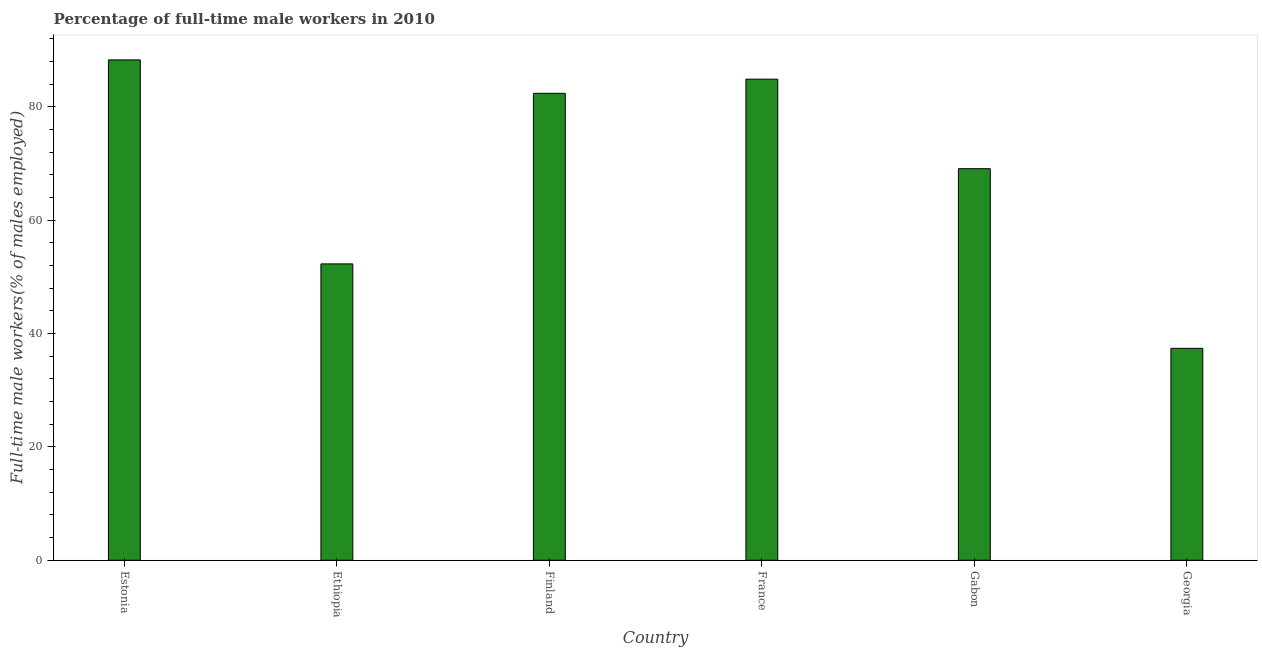What is the title of the graph?
Provide a succinct answer. Percentage of full-time male workers in 2010. What is the label or title of the X-axis?
Your response must be concise. Country. What is the label or title of the Y-axis?
Provide a short and direct response. Full-time male workers(% of males employed). What is the percentage of full-time male workers in Finland?
Your response must be concise. 82.4. Across all countries, what is the maximum percentage of full-time male workers?
Your answer should be very brief. 88.3. Across all countries, what is the minimum percentage of full-time male workers?
Your answer should be compact. 37.4. In which country was the percentage of full-time male workers maximum?
Provide a short and direct response. Estonia. In which country was the percentage of full-time male workers minimum?
Keep it short and to the point. Georgia. What is the sum of the percentage of full-time male workers?
Provide a succinct answer. 414.4. What is the average percentage of full-time male workers per country?
Make the answer very short. 69.07. What is the median percentage of full-time male workers?
Give a very brief answer. 75.75. In how many countries, is the percentage of full-time male workers greater than 72 %?
Make the answer very short. 3. What is the ratio of the percentage of full-time male workers in Ethiopia to that in Gabon?
Your response must be concise. 0.76. Is the sum of the percentage of full-time male workers in Ethiopia and France greater than the maximum percentage of full-time male workers across all countries?
Ensure brevity in your answer.  Yes. What is the difference between the highest and the lowest percentage of full-time male workers?
Offer a terse response. 50.9. In how many countries, is the percentage of full-time male workers greater than the average percentage of full-time male workers taken over all countries?
Ensure brevity in your answer.  4. How many bars are there?
Your answer should be compact. 6. Are all the bars in the graph horizontal?
Your answer should be very brief. No. How many countries are there in the graph?
Provide a short and direct response. 6. What is the Full-time male workers(% of males employed) in Estonia?
Make the answer very short. 88.3. What is the Full-time male workers(% of males employed) of Ethiopia?
Your response must be concise. 52.3. What is the Full-time male workers(% of males employed) of Finland?
Give a very brief answer. 82.4. What is the Full-time male workers(% of males employed) of France?
Offer a terse response. 84.9. What is the Full-time male workers(% of males employed) of Gabon?
Keep it short and to the point. 69.1. What is the Full-time male workers(% of males employed) of Georgia?
Your response must be concise. 37.4. What is the difference between the Full-time male workers(% of males employed) in Estonia and Gabon?
Provide a succinct answer. 19.2. What is the difference between the Full-time male workers(% of males employed) in Estonia and Georgia?
Make the answer very short. 50.9. What is the difference between the Full-time male workers(% of males employed) in Ethiopia and Finland?
Offer a very short reply. -30.1. What is the difference between the Full-time male workers(% of males employed) in Ethiopia and France?
Offer a terse response. -32.6. What is the difference between the Full-time male workers(% of males employed) in Ethiopia and Gabon?
Your response must be concise. -16.8. What is the difference between the Full-time male workers(% of males employed) in Finland and France?
Your response must be concise. -2.5. What is the difference between the Full-time male workers(% of males employed) in Finland and Georgia?
Provide a short and direct response. 45. What is the difference between the Full-time male workers(% of males employed) in France and Gabon?
Provide a succinct answer. 15.8. What is the difference between the Full-time male workers(% of males employed) in France and Georgia?
Provide a succinct answer. 47.5. What is the difference between the Full-time male workers(% of males employed) in Gabon and Georgia?
Your response must be concise. 31.7. What is the ratio of the Full-time male workers(% of males employed) in Estonia to that in Ethiopia?
Ensure brevity in your answer.  1.69. What is the ratio of the Full-time male workers(% of males employed) in Estonia to that in Finland?
Keep it short and to the point. 1.07. What is the ratio of the Full-time male workers(% of males employed) in Estonia to that in Gabon?
Your answer should be very brief. 1.28. What is the ratio of the Full-time male workers(% of males employed) in Estonia to that in Georgia?
Offer a terse response. 2.36. What is the ratio of the Full-time male workers(% of males employed) in Ethiopia to that in Finland?
Offer a very short reply. 0.64. What is the ratio of the Full-time male workers(% of males employed) in Ethiopia to that in France?
Provide a short and direct response. 0.62. What is the ratio of the Full-time male workers(% of males employed) in Ethiopia to that in Gabon?
Make the answer very short. 0.76. What is the ratio of the Full-time male workers(% of males employed) in Ethiopia to that in Georgia?
Make the answer very short. 1.4. What is the ratio of the Full-time male workers(% of males employed) in Finland to that in France?
Keep it short and to the point. 0.97. What is the ratio of the Full-time male workers(% of males employed) in Finland to that in Gabon?
Your answer should be compact. 1.19. What is the ratio of the Full-time male workers(% of males employed) in Finland to that in Georgia?
Keep it short and to the point. 2.2. What is the ratio of the Full-time male workers(% of males employed) in France to that in Gabon?
Offer a terse response. 1.23. What is the ratio of the Full-time male workers(% of males employed) in France to that in Georgia?
Offer a terse response. 2.27. What is the ratio of the Full-time male workers(% of males employed) in Gabon to that in Georgia?
Ensure brevity in your answer.  1.85. 